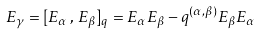<formula> <loc_0><loc_0><loc_500><loc_500>E _ { \gamma } = [ E _ { \alpha } \, , \, E _ { \beta } ] _ { q } = E _ { \alpha } E _ { \beta } - q ^ { ( \alpha , \beta ) } E _ { \beta } E _ { \alpha }</formula> 